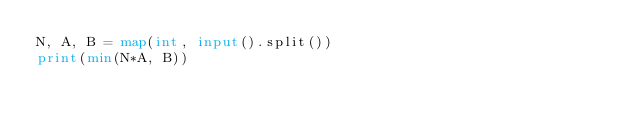Convert code to text. <code><loc_0><loc_0><loc_500><loc_500><_Python_>N, A, B = map(int, input().split())
print(min(N*A, B))</code> 